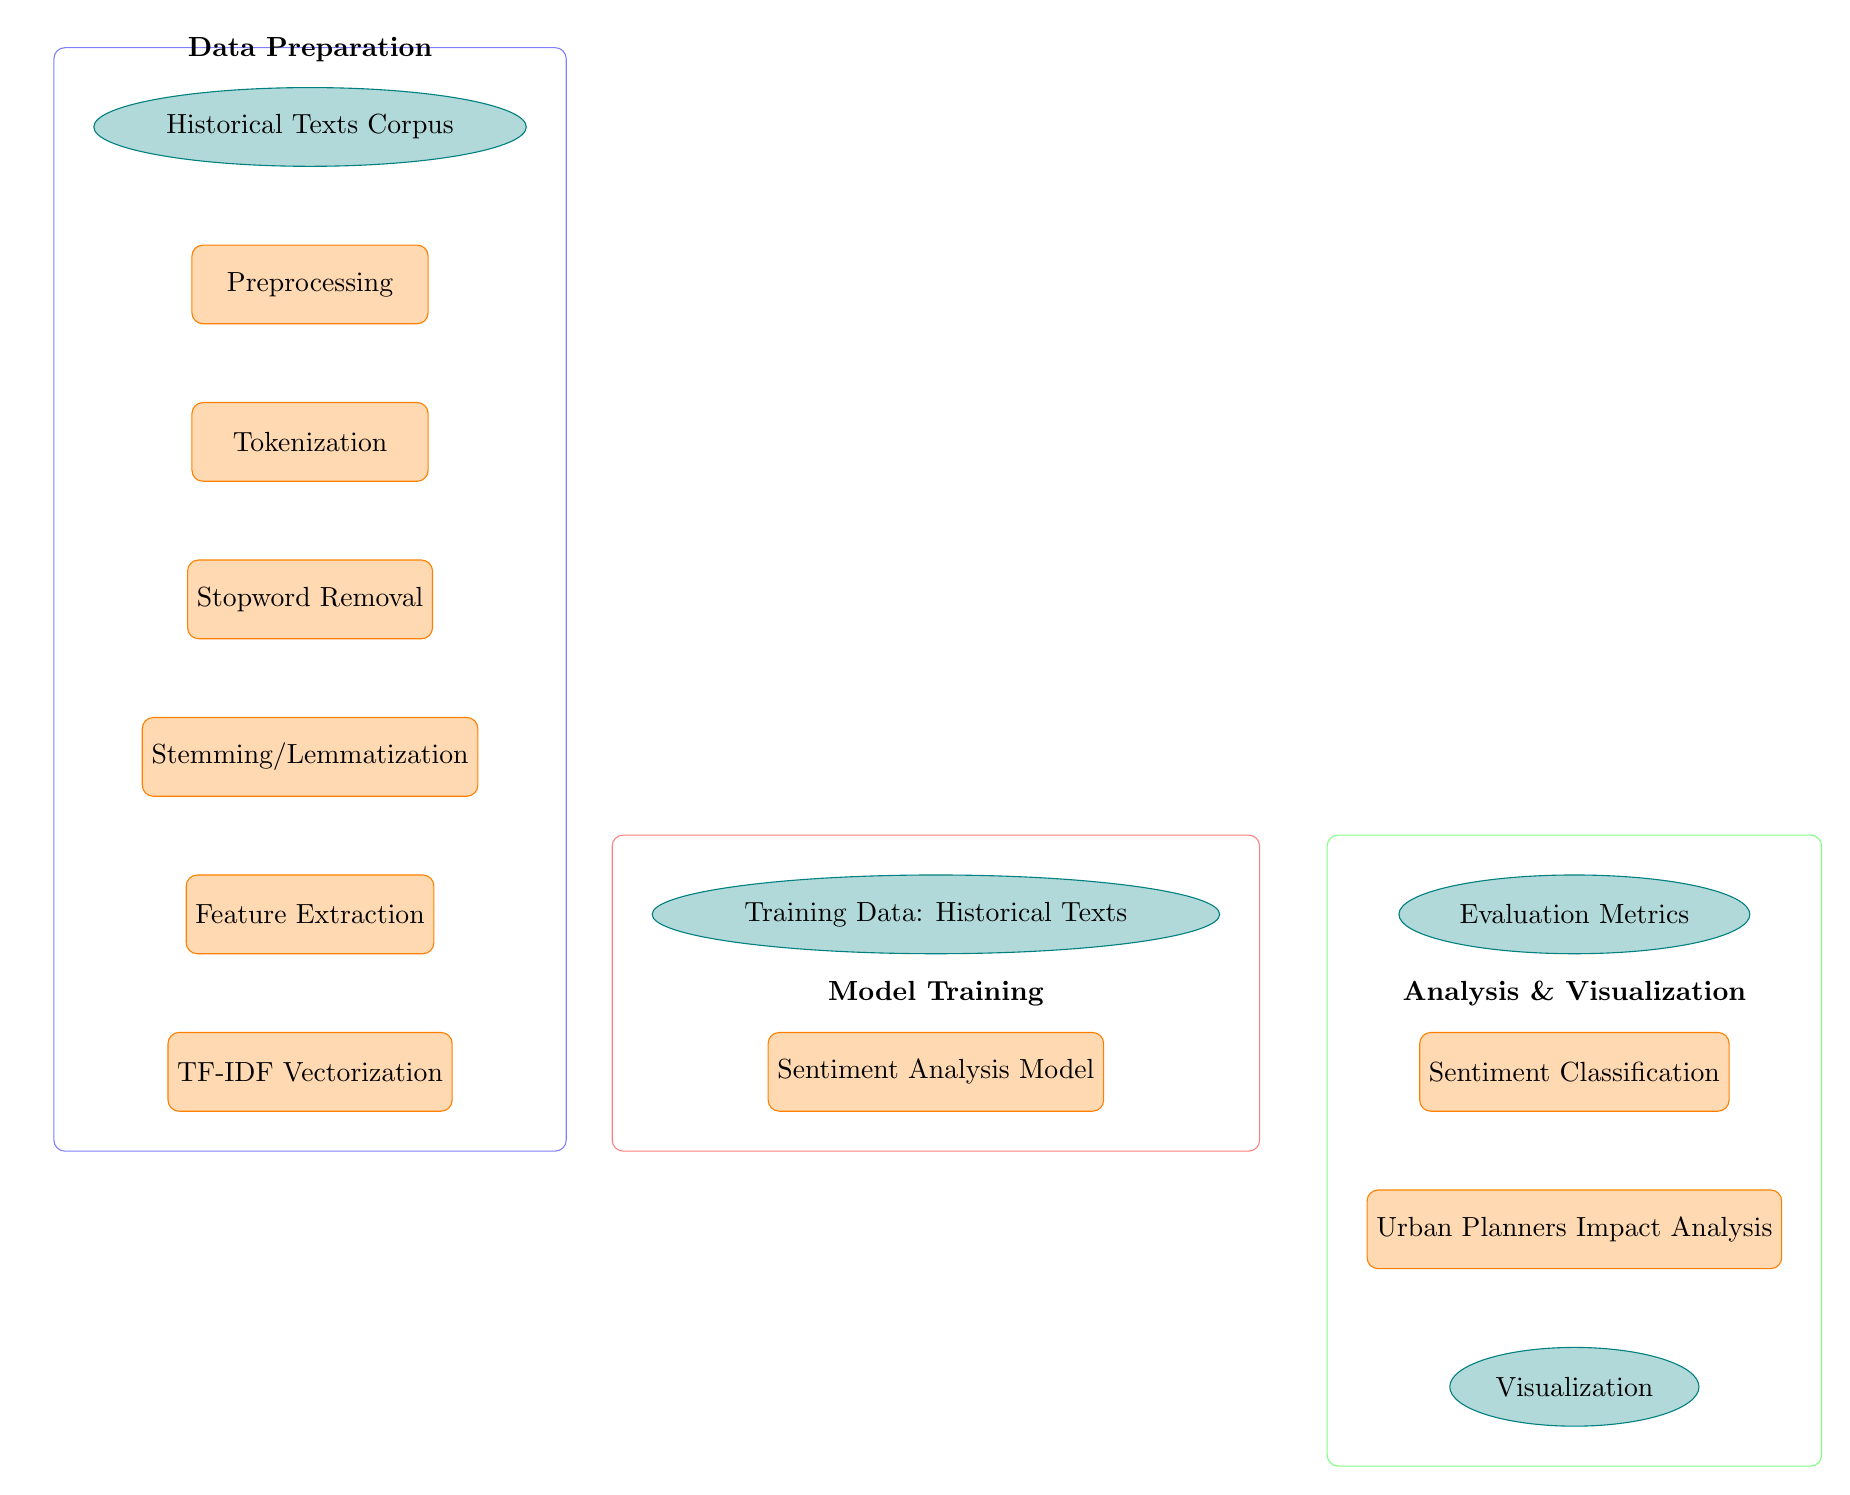What's the first step in the process? The diagram indicates that the first step is labeled as "Historical Texts Corpus," which is categorized as a data node.
Answer: Historical Texts Corpus What follows after Tokenization? The next step following Tokenization is Stopword Removal, which continues the data preprocessing workflow.
Answer: Stopword Removal How many main processes are there in the diagram? By counting the labeled process nodes, there are five main processes listed: Preprocessing, Tokenization, Stopword Removal, Stemming/Lemmatization, and Feature Extraction.
Answer: Five Which model is connected directly to the Training Data? The Sentiment Analysis Model is the node that directly connects to Training Data, depicting the model training phase.
Answer: Sentiment Analysis Model What is the last step of sentiment analysis according to this diagram? The final step outlined in the diagram is Visualization, which indicates that results will be visually represented following the analysis of urban planners' impacts.
Answer: Visualization What is the relationship between the "Sentiment Classification" and "Evaluation Metrics"? The diagram shows an arrow connecting Sentiment Classification to Evaluation Metrics, indicating that the classification output is evaluated using those metrics.
Answer: Evaluation Metrics What determines the features used in the sentiment analysis? The features used in sentiment analysis are determined by the output of the TF-IDF Vectorization process, which converts text data into a numerical format for analysis.
Answer: TF-IDF Vectorization Which nodes are grouped in the Analysis & Visualization section? The nodes grouped in the Analysis & Visualization section are Sentiment Classification, Evaluation Metrics, Urban Planners Impact Analysis, and Visualization.
Answer: Sentiment Classification, Evaluation Metrics, Urban Planners Impact Analysis, Visualization What arrows indicate the flow from preprocessing to feature extraction? The arrows indicate the sequence of steps starting from the corpus through preprocessing, tokenization, stopword removal, stemming/lemmatization, and finally leading to feature extraction.
Answer: Feature Extraction 